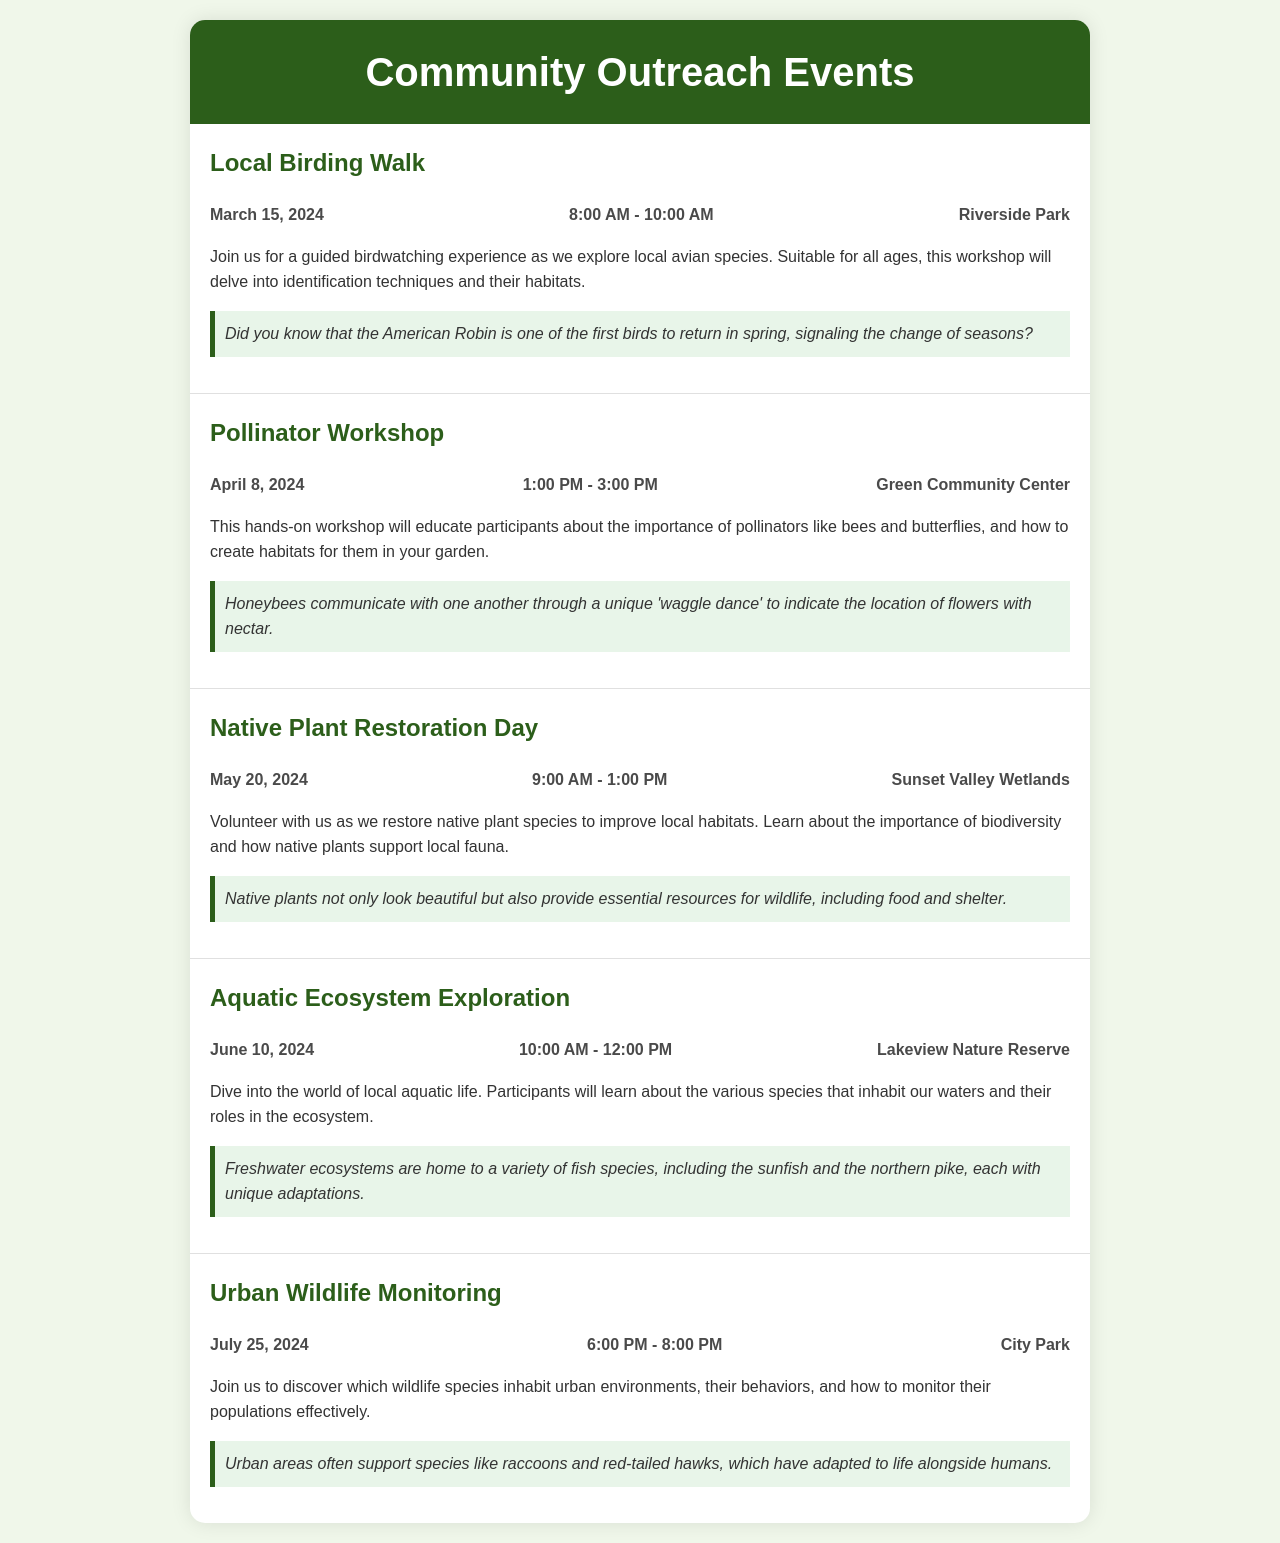What is the date of the Local Birding Walk? The date of the Local Birding Walk is stated in the event details section of the document.
Answer: March 15, 2024 What is the location of the Pollinator Workshop? The location is provided in the event details for the Pollinator Workshop.
Answer: Green Community Center What time does the Native Plant Restoration Day start? The start time for the Native Plant Restoration Day is included in the time details of the event.
Answer: 9:00 AM Who can participate in the Aquatic Ecosystem Exploration? The document indicates that the Aquatic Ecosystem Exploration is designed for a broad audience.
Answer: All ages What is the main focus of the Urban Wildlife Monitoring event? The focus is described in the event description section of Urban Wildlife Monitoring.
Answer: Wildlife species in urban environments How many total events are listed in the document? The total number of events is derived from the number of event sections present in the document.
Answer: 5 Which event takes place in June? The month of June is specified in the event date for the aquatic exploration activity.
Answer: Aquatic Ecosystem Exploration What is the theme of the fact provided with the Pollinator Workshop? The theme is centered around communication in honeybees, as stated in the event fact.
Answer: Communication What is the duration of the Local Birding Walk? The duration is given in the time details for the Local Birding Walk event.
Answer: 2 hours 